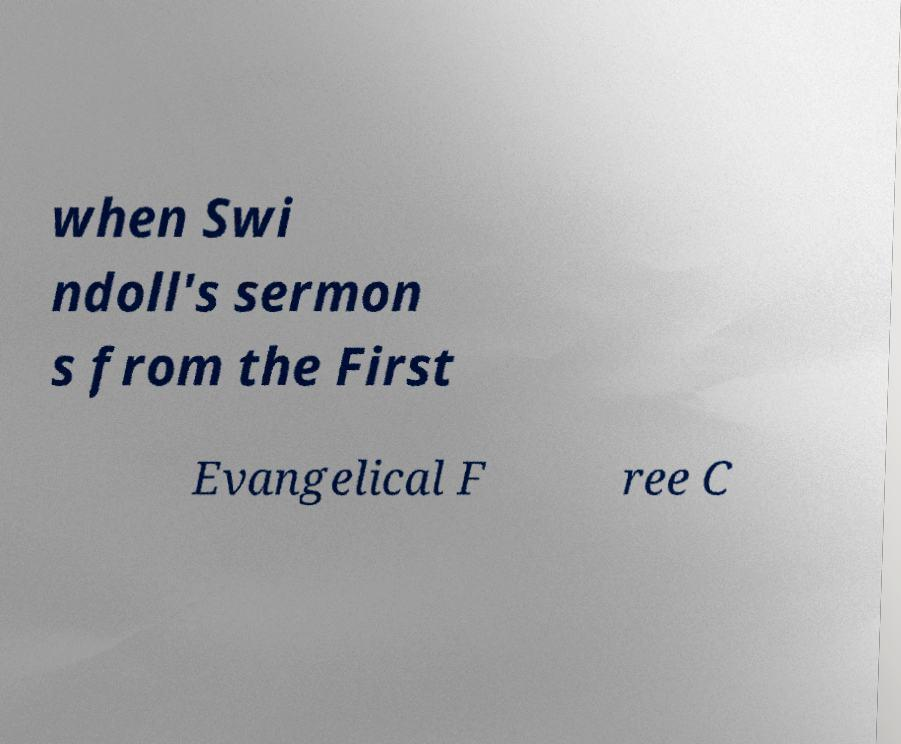What messages or text are displayed in this image? I need them in a readable, typed format. when Swi ndoll's sermon s from the First Evangelical F ree C 